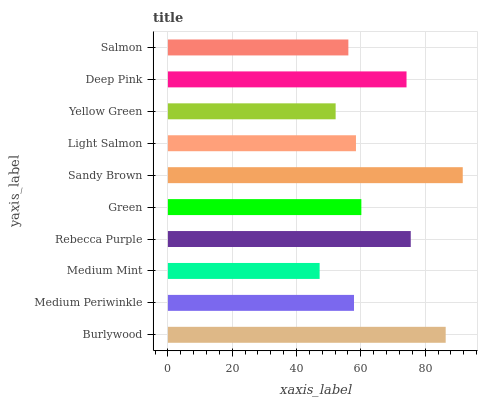Is Medium Mint the minimum?
Answer yes or no. Yes. Is Sandy Brown the maximum?
Answer yes or no. Yes. Is Medium Periwinkle the minimum?
Answer yes or no. No. Is Medium Periwinkle the maximum?
Answer yes or no. No. Is Burlywood greater than Medium Periwinkle?
Answer yes or no. Yes. Is Medium Periwinkle less than Burlywood?
Answer yes or no. Yes. Is Medium Periwinkle greater than Burlywood?
Answer yes or no. No. Is Burlywood less than Medium Periwinkle?
Answer yes or no. No. Is Green the high median?
Answer yes or no. Yes. Is Light Salmon the low median?
Answer yes or no. Yes. Is Rebecca Purple the high median?
Answer yes or no. No. Is Rebecca Purple the low median?
Answer yes or no. No. 